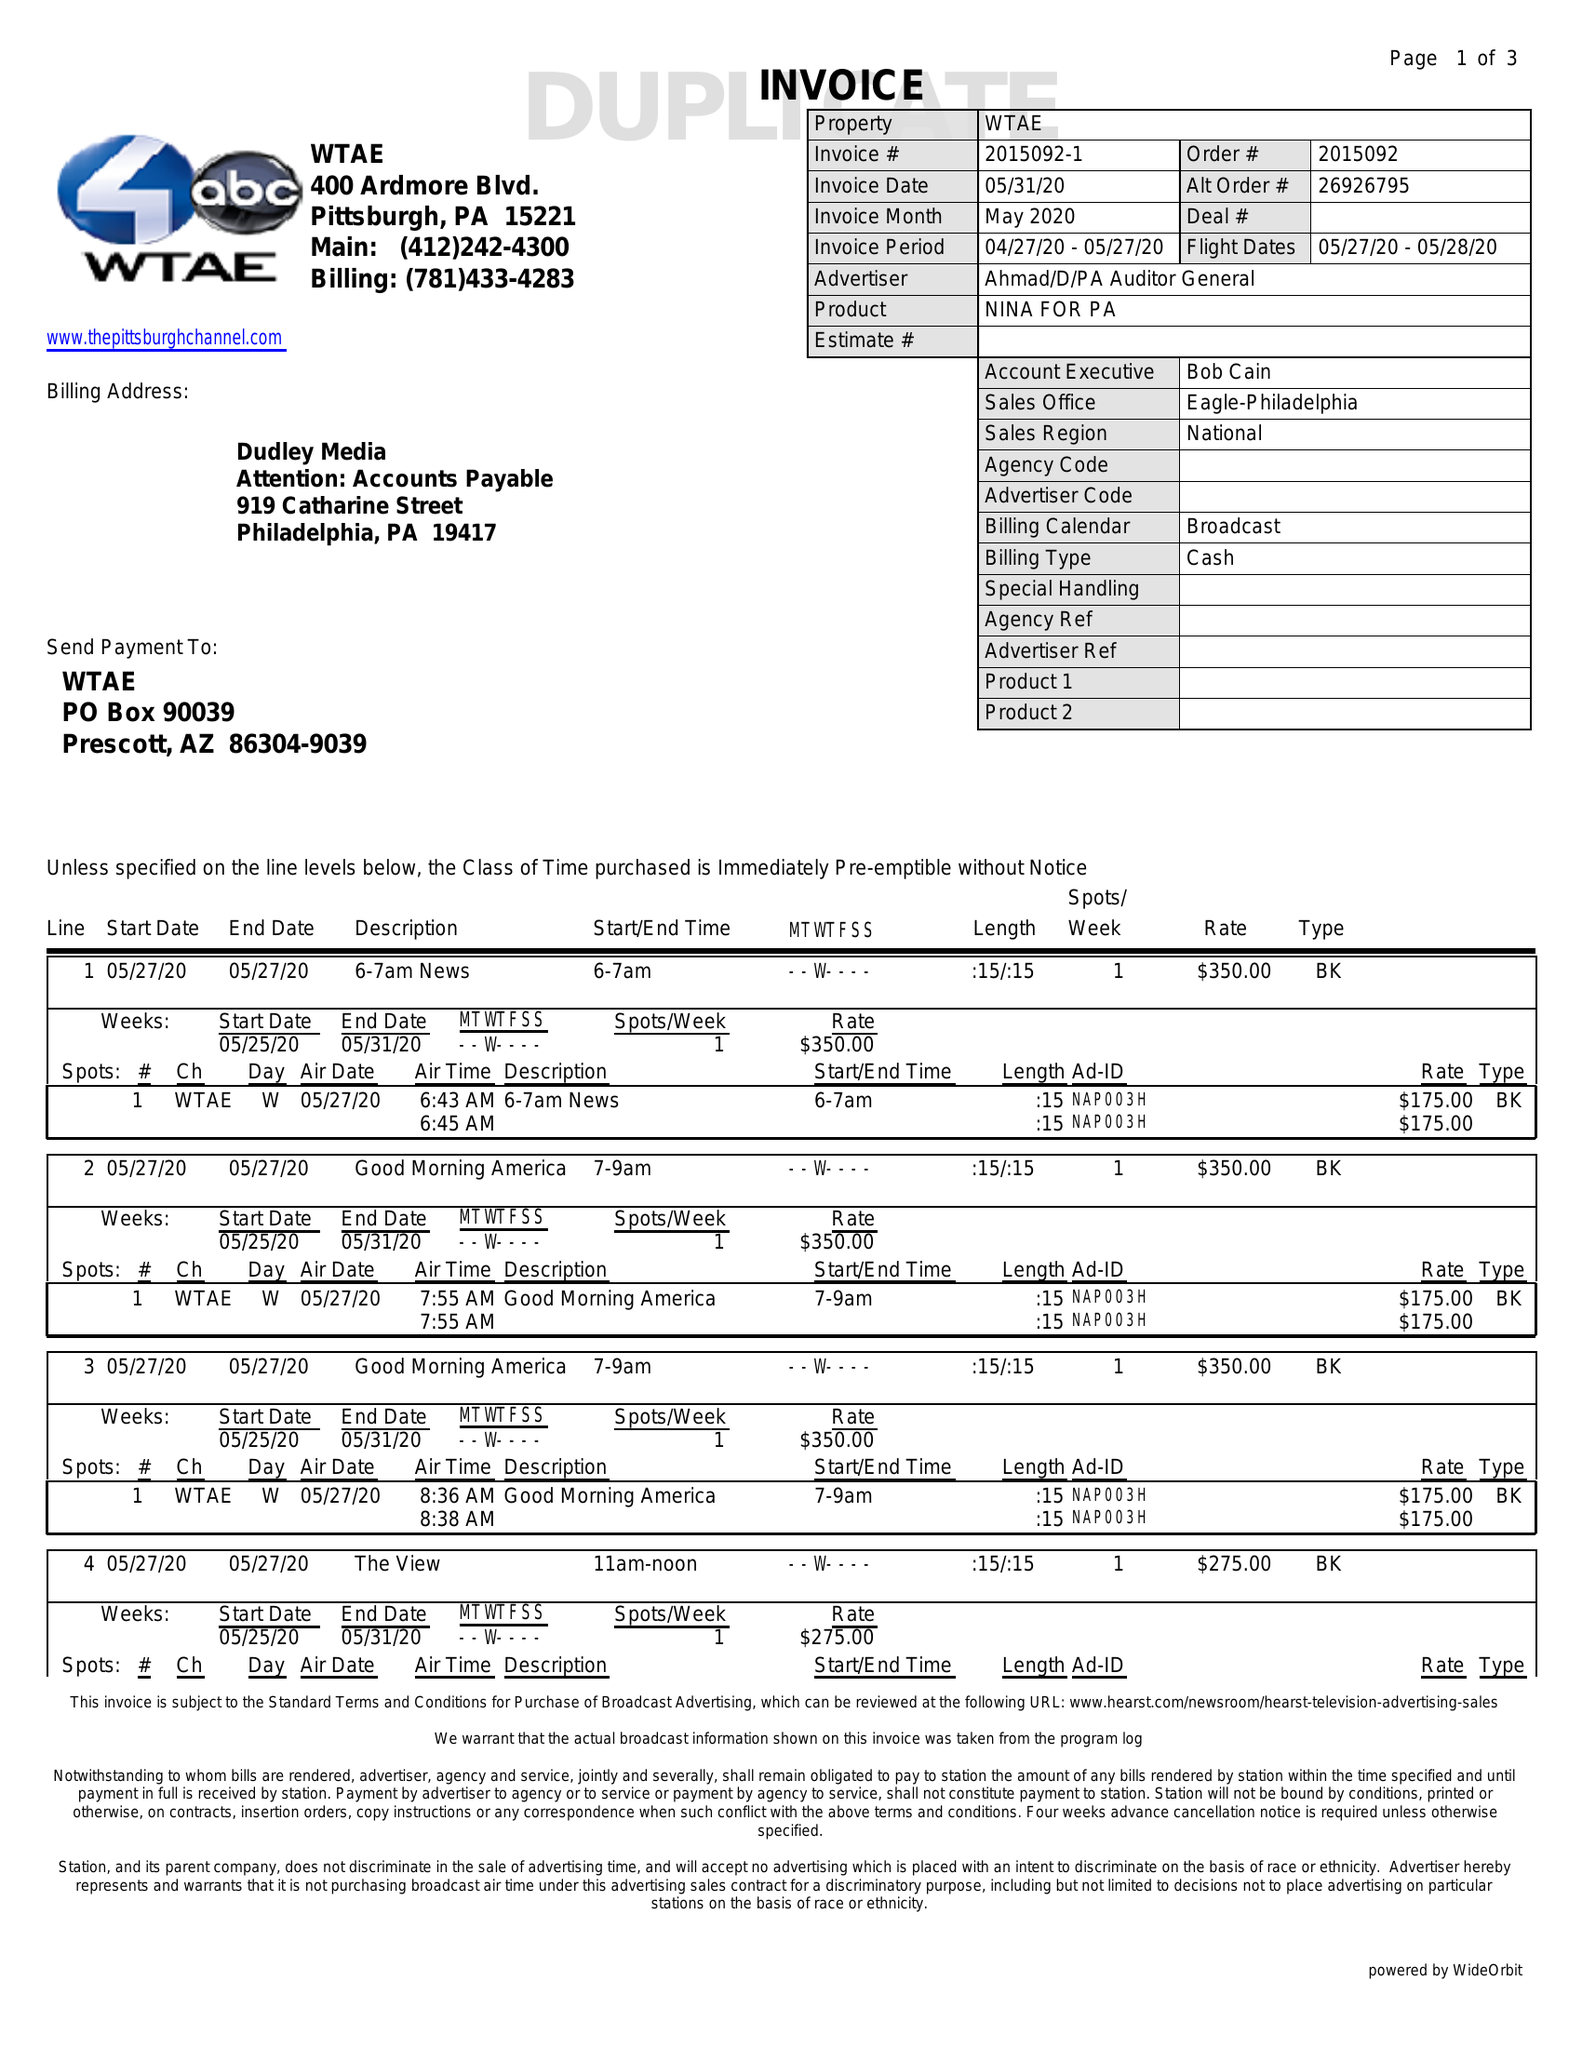What is the value for the gross_amount?
Answer the question using a single word or phrase. 3575.00 